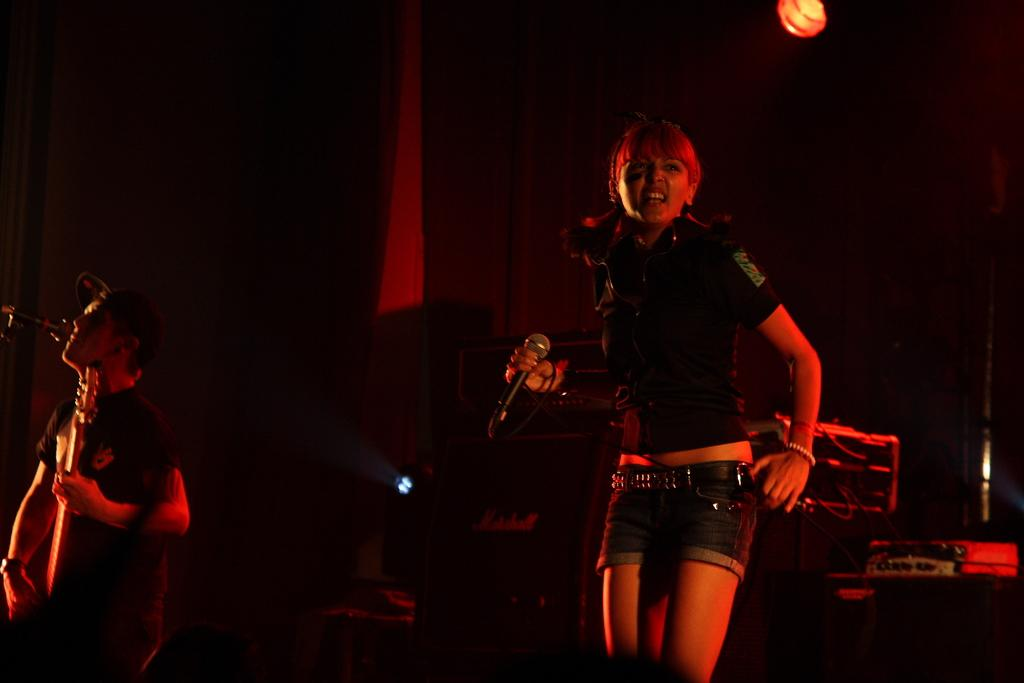How many people are in the image? There are two persons in the image. What are the people wearing? Both persons are wearing black color dress. What are the people doing in the image? The persons are playing musical instruments and singing together. What can be seen in the background of the image? There is a black color sheet in the background of the image. What type of committee meeting is taking place in the image? There is no committee meeting present in the image; it features two people playing musical instruments and singing together. Can you see any ghosts in the image? There are no ghosts present in the image. 